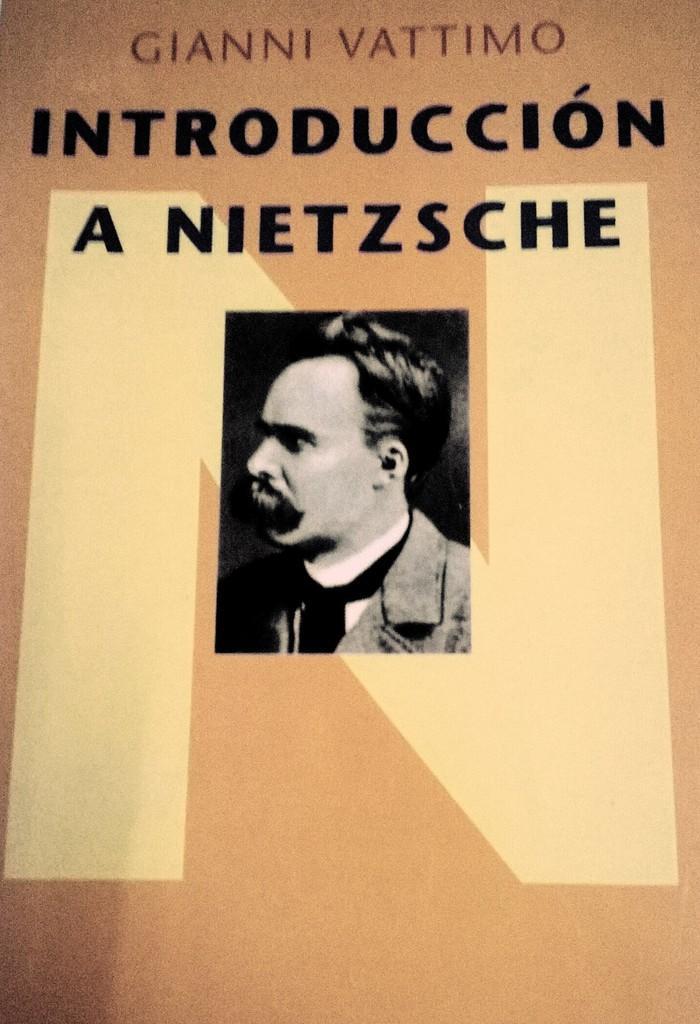Could you give a brief overview of what you see in this image? In this image, we can see a photo, there is a picture of a man and some text on the photo. 